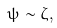<formula> <loc_0><loc_0><loc_500><loc_500>\psi \sim \zeta ,</formula> 